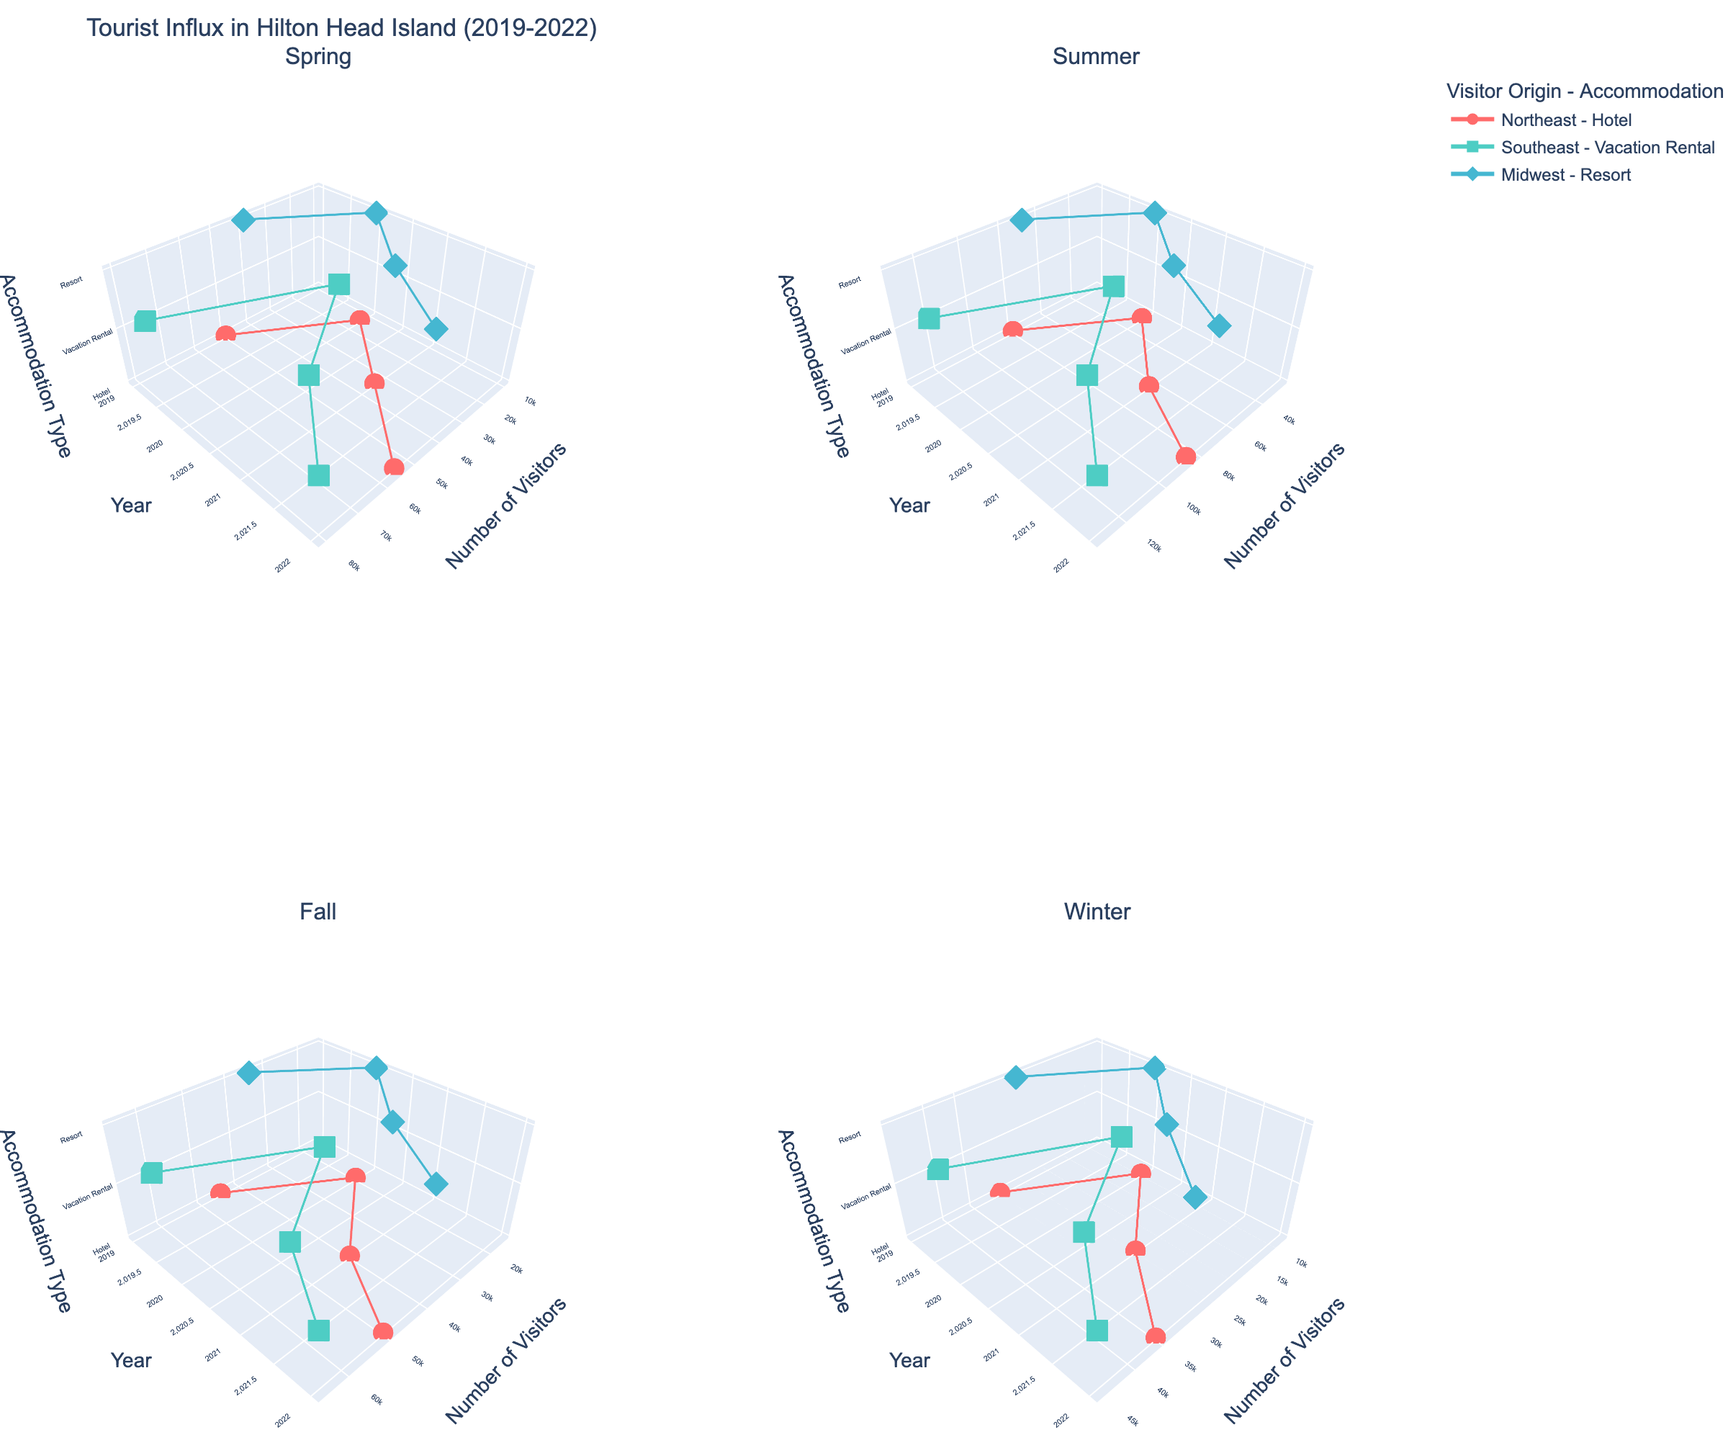What is the title of the figure? The title is displayed at the top of the figure. It gives an overview of what the figure is about.
Answer: Tourist Influx in Hilton Head Island (2019-2022) What is the main color used to represent visitors from the Northeast? The color can be identified by looking at the markers or lines associated with Northeast-origin data points in the plots.
Answer: Red In which season did Southeast visitors staying in vacation rentals have the highest number of visitors in 2021? Look for the season subplot where Southeast visitors and Vacation Rental accommodation are plotted and check the data point for 2021.
Answer: Summer How many years are displayed in the timeline of the plot? The years can be counted along the y-axis of any of the subplots.
Answer: Four (2019, 2020, 2021, 2022) Between 2019 and 2022, how did the number of visitors from the Midwest staying in resorts change in the Winter? Check the Winter subplot for Midwest-origin and Resort accommodation data points. Compare the visitor numbers for each year.
Answer: Increased from 25,000 to 30,000 Which accommodation type had a notable decrease in visitors from the Midwest between Spring and Summer of 2020? Look at the Spring and Summer subplots and compare Midwest-origin data points for 2020, focusing on each accommodation type.
Answer: Resort During which year did the visitors from the Southeast staying in vacation rentals sharply increase in number from the previous year? Examine the Southeast-origin and Vacation Rental accommodation data points across the years for noticeable changes.
Answer: 2021 On average, which accommodation type saw the most visitors across all seasons in 2019? Find the average visitors for each accommodation type across all seasons in 2019 and compare them.
Answer: Vacation Rental In Fall, did the number of visitors from the Northeast staying in hotels increase or decrease from 2019 to 2020? Look at the Fall subplot for Northeast-origin and Hotel accommodation data. Compare the number of visitors between 2019 and 2020.
Answer: Decrease For which visitor origin and accommodation type did the number of visitors almost return to 2019 levels by 2022? Compare the number of visitors in 2019 and 2022 for different origins and accommodation types to find the closest match.
Answer: Northeast - Hotel 